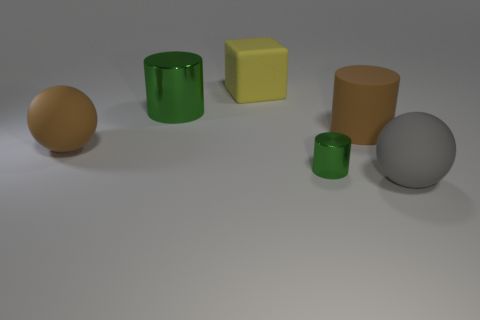Are there more large balls that are in front of the small green object than large yellow cylinders?
Offer a very short reply. Yes. Does the big green object have the same shape as the tiny object?
Give a very brief answer. Yes. Are there more small cylinders left of the gray matte object than yellow matte cubes to the left of the large yellow object?
Your response must be concise. Yes. Are there any big green metal things in front of the big gray rubber sphere?
Your response must be concise. No. Is there a green object of the same size as the cube?
Make the answer very short. Yes. There is a large cylinder that is made of the same material as the yellow object; what is its color?
Offer a terse response. Brown. What is the material of the brown cylinder?
Make the answer very short. Rubber. The large metallic object is what shape?
Provide a succinct answer. Cylinder. How many matte cylinders have the same color as the block?
Ensure brevity in your answer.  0. What is the green cylinder that is behind the cylinder that is right of the shiny object that is on the right side of the large matte cube made of?
Provide a short and direct response. Metal. 